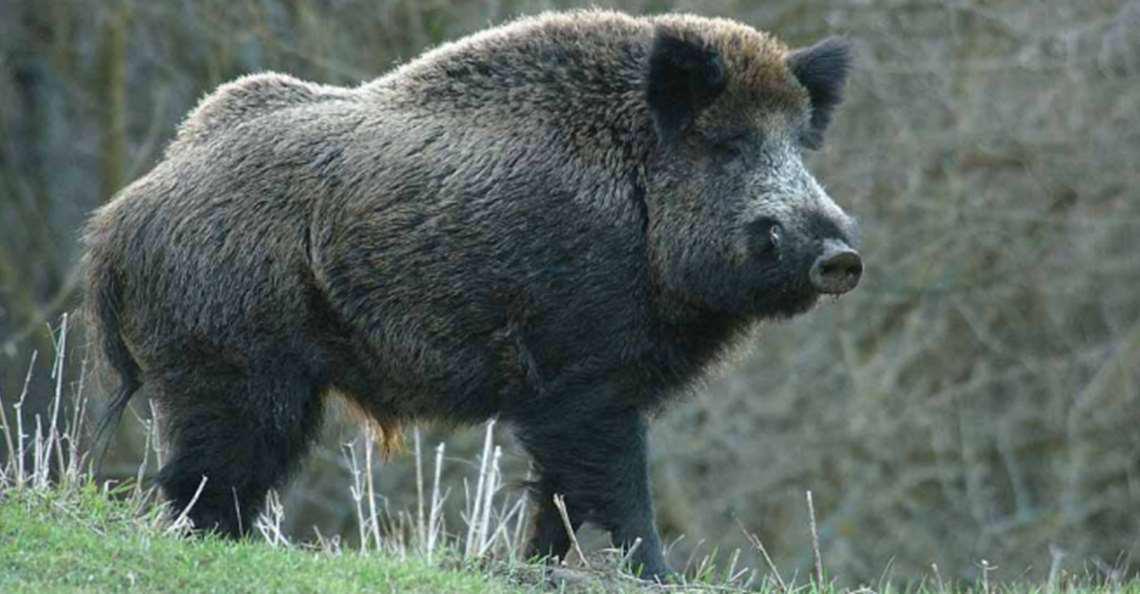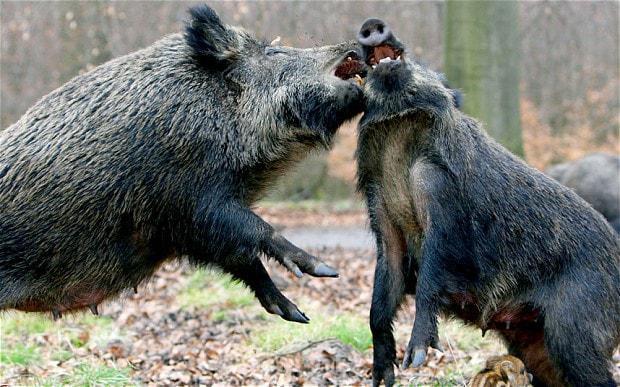The first image is the image on the left, the second image is the image on the right. Analyze the images presented: Is the assertion "There are exactly three animals." valid? Answer yes or no. Yes. 